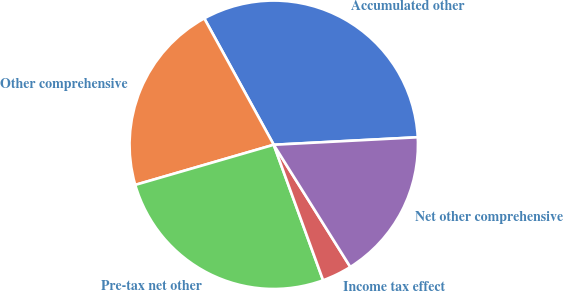<chart> <loc_0><loc_0><loc_500><loc_500><pie_chart><fcel>Accumulated other<fcel>Other comprehensive<fcel>Pre-tax net other<fcel>Income tax effect<fcel>Net other comprehensive<nl><fcel>32.17%<fcel>21.49%<fcel>26.07%<fcel>3.35%<fcel>16.92%<nl></chart> 